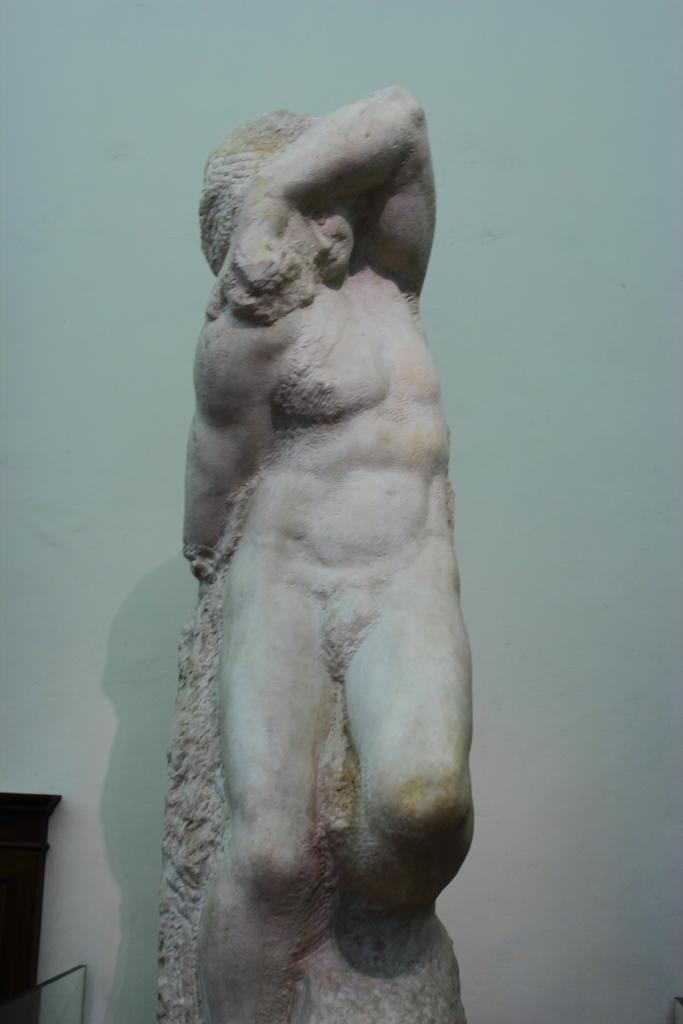What is the main subject of the image? There is a statue of a person in the image. What can be seen to the left of the statue? There is a black color object to the left of the statue. What is visible in the background of the image? There is a wall in the background of the image. Can you tell me how many beasts are running towards the statue in the image? There are no beasts or running depicted in the image; it features a statue and a black object to the left. 